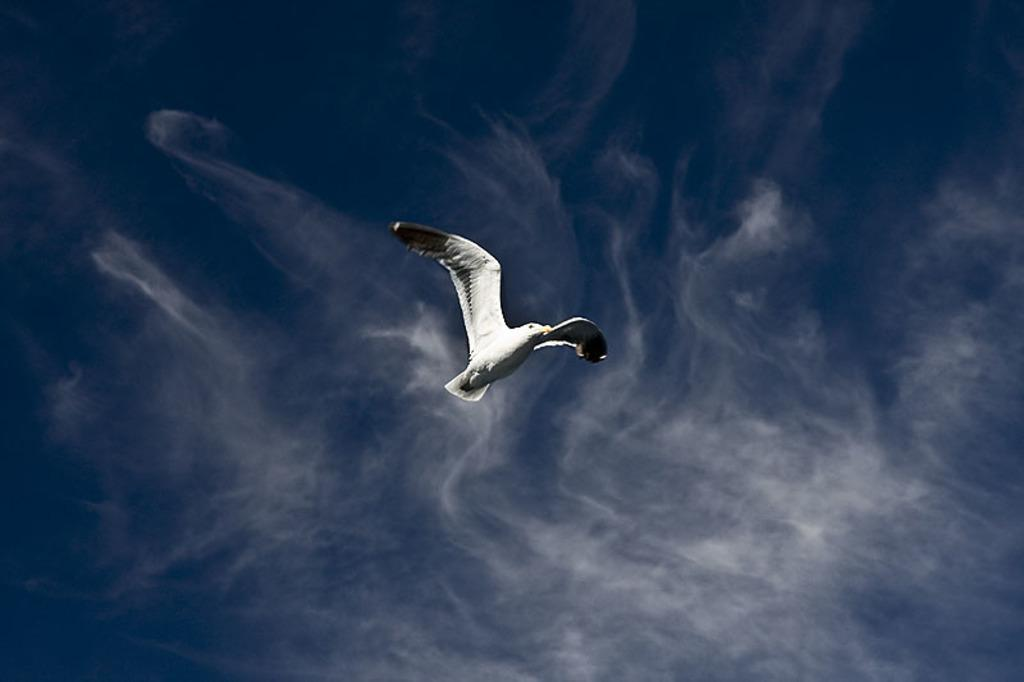What type of animal is in the image? There is a bird in the image. What is the bird doing in the image? The bird is flying in the image. Where is the bird located in the image? The bird is in the sky in the image. What can be seen in the sky with the bird? There are clouds visible in the image. What type of snake can be seen in the image? There is no snake present in the image. 